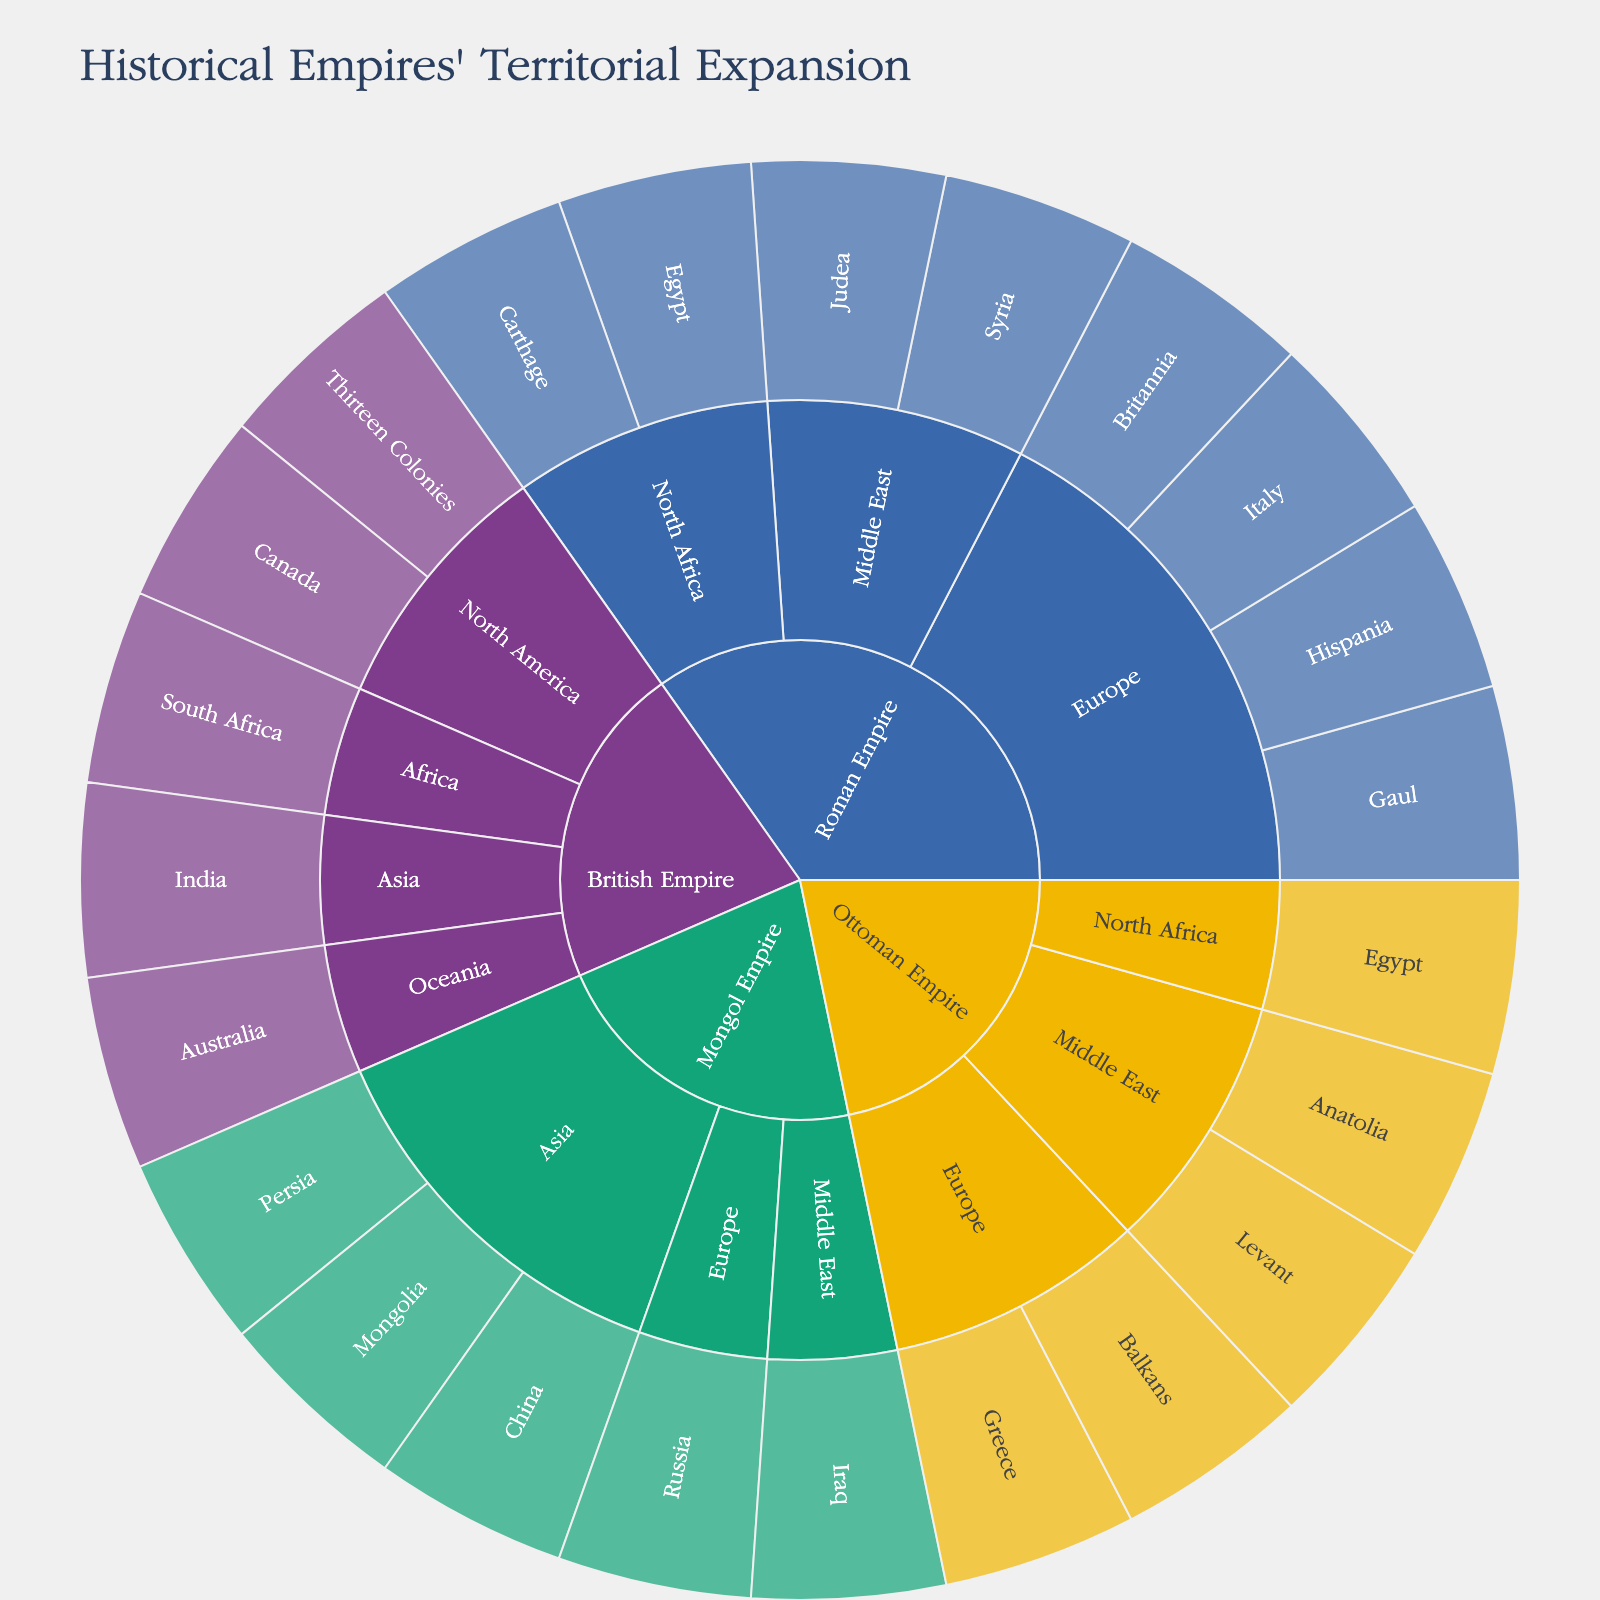What are the main empires shown in the plot? By looking at the outermost labeled sections, you can identify the distinct layers, each representing a different empire.
Answer: Roman Empire, Mongol Empire, Ottoman Empire, British Empire Which regions did the Roman Empire conquer in Europe? Locate the Roman Empire layer and then follow inward to the Europe segment. Observe the subregions listed under Europe.
Answer: Italy, Gaul, Hispania, Britannia How many subregions did the British Empire conquer in North America? Look for the North America region under the British Empire layer and count the subregions within it.
Answer: 2 How does the territorial expansion of the Mongol Empire in Asia compare to that of the Roman Empire in Europe? Observe the sections under the Mongol Empire in Asia and compare them to the sections under the Roman Empire in Europe. Count the number of subregions in each.
Answer: Mongol Empire: 3, Roman Empire: 4 Which empire has regions in the Middle East? Identify the various regions under each empire. Locate the Middle East and see to which empires it is connected.
Answer: Roman Empire, Mongol Empire, Ottoman Empire Which subregion is shared by both the Roman Empire and the Ottoman Empire? Analyze the subregions listed under both the Roman Empire and the Ottoman Empire. Look for common names.
Answer: Egypt How many subregions does the Mongol Empire have in total? Sum up the subregions listed under the Mongol Empire regardless of their regions.
Answer: 5 What is the most diversified empire in terms of regions conquered? Determine which empire has conquered the most unique regions by counting the total regional segments under each empire's layer.
Answer: British Empire Which empire's expansion includes Australasia/Oceania? Look for the empire connected to the Oceania region in the plot.
Answer: British Empire How does the British Empire's presence in Asia compare to its presence in Africa? Compare the subregions listed under Asia and Africa for the British Empire by counting the number of subregions in each.
Answer: Asia: 1, Africa: 1 